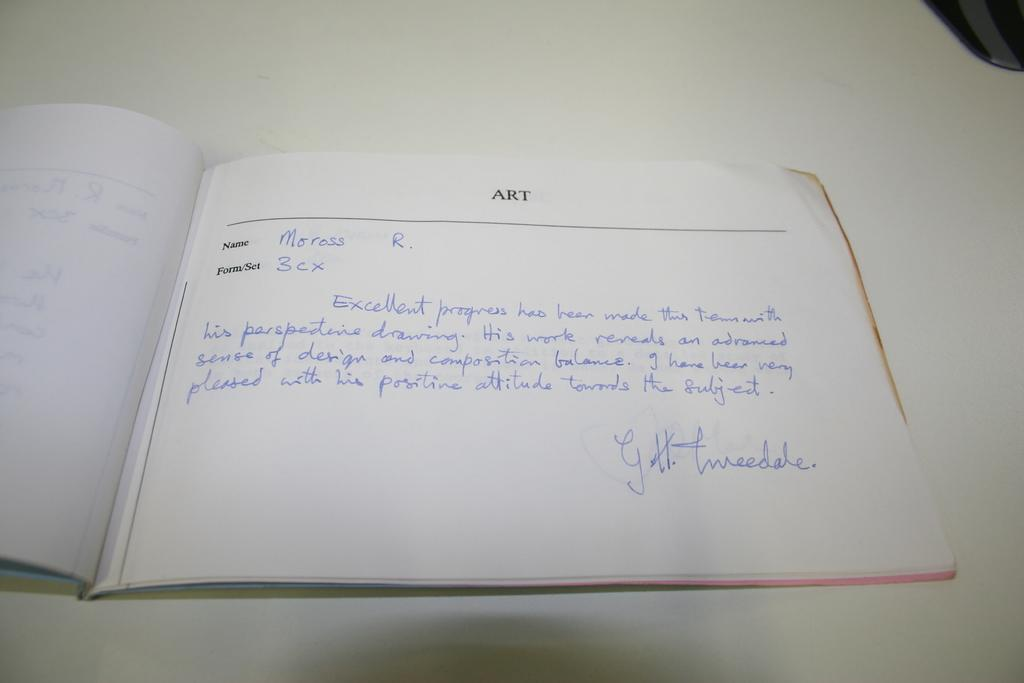Provide a one-sentence caption for the provided image. the word art is on a white piece of paper. 